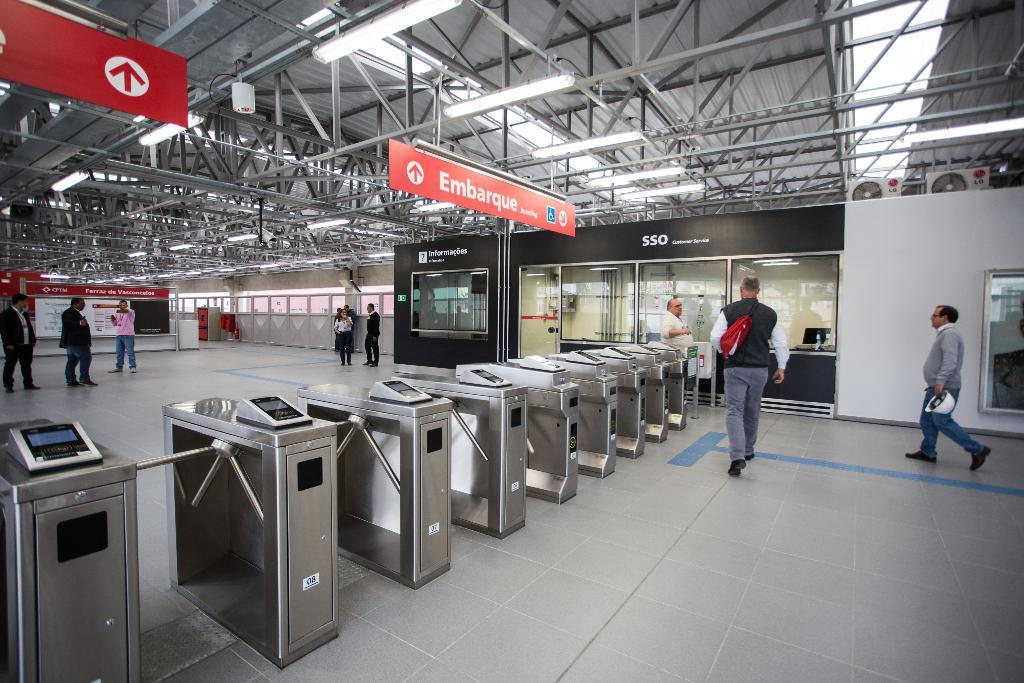<image>
Describe the image concisely. an orange sign with the word Embarque at the top 